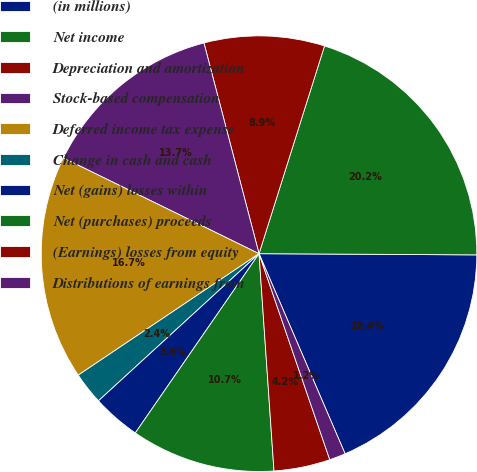Convert chart. <chart><loc_0><loc_0><loc_500><loc_500><pie_chart><fcel>(in millions)<fcel>Net income<fcel>Depreciation and amortization<fcel>Stock-based compensation<fcel>Deferred income tax expense<fcel>Change in cash and cash<fcel>Net (gains) losses within<fcel>Net (purchases) proceeds<fcel>(Earnings) losses from equity<fcel>Distributions of earnings from<nl><fcel>18.45%<fcel>20.23%<fcel>8.93%<fcel>13.69%<fcel>16.66%<fcel>2.39%<fcel>3.58%<fcel>10.71%<fcel>4.17%<fcel>1.2%<nl></chart> 